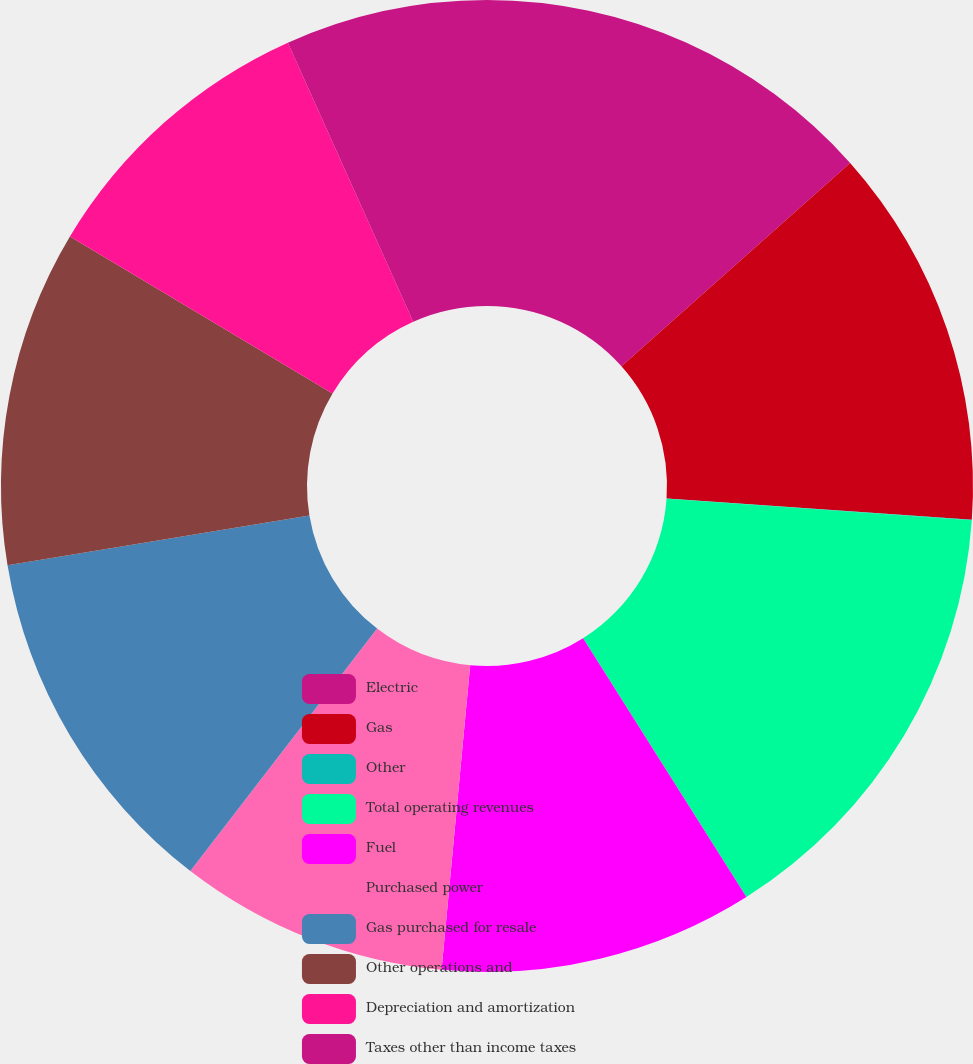Convert chart to OTSL. <chart><loc_0><loc_0><loc_500><loc_500><pie_chart><fcel>Electric<fcel>Gas<fcel>Other<fcel>Total operating revenues<fcel>Fuel<fcel>Purchased power<fcel>Gas purchased for resale<fcel>Other operations and<fcel>Depreciation and amortization<fcel>Taxes other than income taxes<nl><fcel>13.43%<fcel>12.68%<fcel>0.01%<fcel>14.92%<fcel>10.45%<fcel>8.96%<fcel>11.94%<fcel>11.19%<fcel>9.7%<fcel>6.72%<nl></chart> 